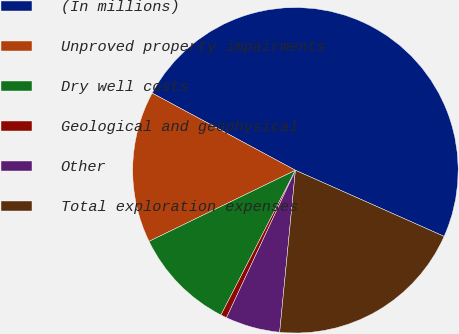Convert chart to OTSL. <chart><loc_0><loc_0><loc_500><loc_500><pie_chart><fcel>(In millions)<fcel>Unproved property impairments<fcel>Dry well costs<fcel>Geological and geophysical<fcel>Other<fcel>Total exploration expenses<nl><fcel>48.79%<fcel>15.06%<fcel>10.24%<fcel>0.6%<fcel>5.42%<fcel>19.88%<nl></chart> 